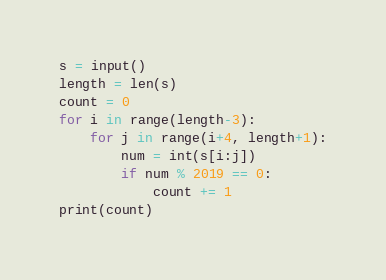Convert code to text. <code><loc_0><loc_0><loc_500><loc_500><_Python_>s = input()
length = len(s)
count = 0
for i in range(length-3):
    for j in range(i+4, length+1):
        num = int(s[i:j])
        if num % 2019 == 0:
            count += 1
print(count)
</code> 